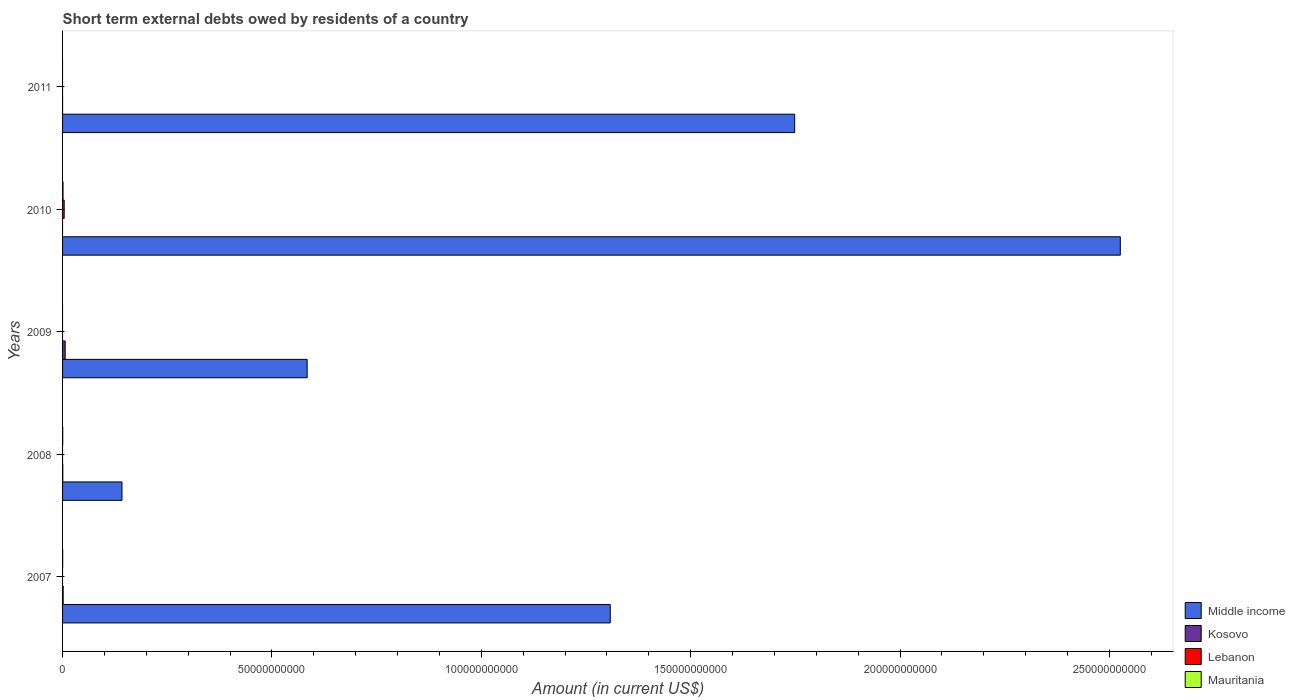How many different coloured bars are there?
Provide a short and direct response. 4. How many groups of bars are there?
Give a very brief answer. 5. Are the number of bars per tick equal to the number of legend labels?
Ensure brevity in your answer.  No. Are the number of bars on each tick of the Y-axis equal?
Your response must be concise. No. How many bars are there on the 1st tick from the top?
Your response must be concise. 2. How many bars are there on the 2nd tick from the bottom?
Your answer should be very brief. 3. What is the label of the 1st group of bars from the top?
Ensure brevity in your answer.  2011. Across all years, what is the maximum amount of short-term external debts owed by residents in Mauritania?
Your answer should be compact. 1.03e+08. Across all years, what is the minimum amount of short-term external debts owed by residents in Mauritania?
Your answer should be compact. 0. What is the total amount of short-term external debts owed by residents in Kosovo in the graph?
Make the answer very short. 8.22e+08. What is the difference between the amount of short-term external debts owed by residents in Middle income in 2009 and that in 2011?
Your answer should be compact. -1.16e+11. What is the difference between the amount of short-term external debts owed by residents in Middle income in 2010 and the amount of short-term external debts owed by residents in Mauritania in 2008?
Ensure brevity in your answer.  2.53e+11. What is the average amount of short-term external debts owed by residents in Middle income per year?
Make the answer very short. 1.26e+11. In the year 2010, what is the difference between the amount of short-term external debts owed by residents in Middle income and amount of short-term external debts owed by residents in Mauritania?
Offer a terse response. 2.52e+11. In how many years, is the amount of short-term external debts owed by residents in Lebanon greater than 160000000000 US$?
Make the answer very short. 0. What is the ratio of the amount of short-term external debts owed by residents in Kosovo in 2007 to that in 2011?
Make the answer very short. 111.99. What is the difference between the highest and the second highest amount of short-term external debts owed by residents in Middle income?
Ensure brevity in your answer.  7.78e+1. What is the difference between the highest and the lowest amount of short-term external debts owed by residents in Middle income?
Provide a succinct answer. 2.38e+11. Is the sum of the amount of short-term external debts owed by residents in Middle income in 2008 and 2011 greater than the maximum amount of short-term external debts owed by residents in Kosovo across all years?
Your answer should be very brief. Yes. Is it the case that in every year, the sum of the amount of short-term external debts owed by residents in Lebanon and amount of short-term external debts owed by residents in Kosovo is greater than the sum of amount of short-term external debts owed by residents in Middle income and amount of short-term external debts owed by residents in Mauritania?
Your answer should be compact. No. What is the difference between two consecutive major ticks on the X-axis?
Provide a short and direct response. 5.00e+1. Where does the legend appear in the graph?
Offer a very short reply. Bottom right. How many legend labels are there?
Your answer should be very brief. 4. What is the title of the graph?
Offer a terse response. Short term external debts owed by residents of a country. What is the Amount (in current US$) in Middle income in 2007?
Ensure brevity in your answer.  1.31e+11. What is the Amount (in current US$) of Kosovo in 2007?
Make the answer very short. 1.41e+08. What is the Amount (in current US$) in Lebanon in 2007?
Your response must be concise. 0. What is the Amount (in current US$) of Mauritania in 2007?
Offer a terse response. 2.70e+07. What is the Amount (in current US$) in Middle income in 2008?
Provide a short and direct response. 1.42e+1. What is the Amount (in current US$) in Kosovo in 2008?
Offer a very short reply. 5.36e+07. What is the Amount (in current US$) in Mauritania in 2008?
Make the answer very short. 4.00e+07. What is the Amount (in current US$) in Middle income in 2009?
Your answer should be very brief. 5.84e+1. What is the Amount (in current US$) in Kosovo in 2009?
Provide a succinct answer. 6.27e+08. What is the Amount (in current US$) of Lebanon in 2009?
Make the answer very short. 0. What is the Amount (in current US$) in Mauritania in 2009?
Keep it short and to the point. 0. What is the Amount (in current US$) of Middle income in 2010?
Provide a succinct answer. 2.53e+11. What is the Amount (in current US$) in Kosovo in 2010?
Keep it short and to the point. 0. What is the Amount (in current US$) in Lebanon in 2010?
Provide a short and direct response. 3.86e+08. What is the Amount (in current US$) of Mauritania in 2010?
Provide a short and direct response. 1.03e+08. What is the Amount (in current US$) of Middle income in 2011?
Provide a short and direct response. 1.75e+11. What is the Amount (in current US$) in Kosovo in 2011?
Give a very brief answer. 1.26e+06. What is the Amount (in current US$) in Lebanon in 2011?
Give a very brief answer. 0. What is the Amount (in current US$) of Mauritania in 2011?
Offer a very short reply. 0. Across all years, what is the maximum Amount (in current US$) of Middle income?
Provide a succinct answer. 2.53e+11. Across all years, what is the maximum Amount (in current US$) of Kosovo?
Offer a terse response. 6.27e+08. Across all years, what is the maximum Amount (in current US$) in Lebanon?
Your answer should be very brief. 3.86e+08. Across all years, what is the maximum Amount (in current US$) in Mauritania?
Your response must be concise. 1.03e+08. Across all years, what is the minimum Amount (in current US$) in Middle income?
Your answer should be very brief. 1.42e+1. Across all years, what is the minimum Amount (in current US$) in Kosovo?
Provide a short and direct response. 0. Across all years, what is the minimum Amount (in current US$) of Lebanon?
Offer a very short reply. 0. Across all years, what is the minimum Amount (in current US$) in Mauritania?
Provide a succinct answer. 0. What is the total Amount (in current US$) of Middle income in the graph?
Make the answer very short. 6.31e+11. What is the total Amount (in current US$) in Kosovo in the graph?
Your response must be concise. 8.22e+08. What is the total Amount (in current US$) of Lebanon in the graph?
Ensure brevity in your answer.  3.86e+08. What is the total Amount (in current US$) of Mauritania in the graph?
Make the answer very short. 1.70e+08. What is the difference between the Amount (in current US$) of Middle income in 2007 and that in 2008?
Your answer should be very brief. 1.17e+11. What is the difference between the Amount (in current US$) of Kosovo in 2007 and that in 2008?
Ensure brevity in your answer.  8.71e+07. What is the difference between the Amount (in current US$) in Mauritania in 2007 and that in 2008?
Keep it short and to the point. -1.30e+07. What is the difference between the Amount (in current US$) in Middle income in 2007 and that in 2009?
Your response must be concise. 7.24e+1. What is the difference between the Amount (in current US$) of Kosovo in 2007 and that in 2009?
Your response must be concise. -4.86e+08. What is the difference between the Amount (in current US$) in Middle income in 2007 and that in 2010?
Your response must be concise. -1.22e+11. What is the difference between the Amount (in current US$) of Mauritania in 2007 and that in 2010?
Your answer should be very brief. -7.60e+07. What is the difference between the Amount (in current US$) in Middle income in 2007 and that in 2011?
Your answer should be compact. -4.40e+1. What is the difference between the Amount (in current US$) of Kosovo in 2007 and that in 2011?
Offer a very short reply. 1.39e+08. What is the difference between the Amount (in current US$) of Middle income in 2008 and that in 2009?
Your response must be concise. -4.42e+1. What is the difference between the Amount (in current US$) in Kosovo in 2008 and that in 2009?
Offer a terse response. -5.73e+08. What is the difference between the Amount (in current US$) of Middle income in 2008 and that in 2010?
Give a very brief answer. -2.38e+11. What is the difference between the Amount (in current US$) in Mauritania in 2008 and that in 2010?
Ensure brevity in your answer.  -6.30e+07. What is the difference between the Amount (in current US$) in Middle income in 2008 and that in 2011?
Offer a very short reply. -1.61e+11. What is the difference between the Amount (in current US$) of Kosovo in 2008 and that in 2011?
Provide a short and direct response. 5.23e+07. What is the difference between the Amount (in current US$) of Middle income in 2009 and that in 2010?
Give a very brief answer. -1.94e+11. What is the difference between the Amount (in current US$) of Middle income in 2009 and that in 2011?
Provide a short and direct response. -1.16e+11. What is the difference between the Amount (in current US$) of Kosovo in 2009 and that in 2011?
Your response must be concise. 6.26e+08. What is the difference between the Amount (in current US$) of Middle income in 2010 and that in 2011?
Give a very brief answer. 7.78e+1. What is the difference between the Amount (in current US$) of Middle income in 2007 and the Amount (in current US$) of Kosovo in 2008?
Offer a very short reply. 1.31e+11. What is the difference between the Amount (in current US$) of Middle income in 2007 and the Amount (in current US$) of Mauritania in 2008?
Make the answer very short. 1.31e+11. What is the difference between the Amount (in current US$) of Kosovo in 2007 and the Amount (in current US$) of Mauritania in 2008?
Provide a short and direct response. 1.01e+08. What is the difference between the Amount (in current US$) of Middle income in 2007 and the Amount (in current US$) of Kosovo in 2009?
Ensure brevity in your answer.  1.30e+11. What is the difference between the Amount (in current US$) in Middle income in 2007 and the Amount (in current US$) in Lebanon in 2010?
Provide a short and direct response. 1.30e+11. What is the difference between the Amount (in current US$) of Middle income in 2007 and the Amount (in current US$) of Mauritania in 2010?
Make the answer very short. 1.31e+11. What is the difference between the Amount (in current US$) in Kosovo in 2007 and the Amount (in current US$) in Lebanon in 2010?
Your answer should be compact. -2.45e+08. What is the difference between the Amount (in current US$) in Kosovo in 2007 and the Amount (in current US$) in Mauritania in 2010?
Your answer should be compact. 3.77e+07. What is the difference between the Amount (in current US$) of Middle income in 2007 and the Amount (in current US$) of Kosovo in 2011?
Your response must be concise. 1.31e+11. What is the difference between the Amount (in current US$) of Middle income in 2008 and the Amount (in current US$) of Kosovo in 2009?
Offer a terse response. 1.36e+1. What is the difference between the Amount (in current US$) in Middle income in 2008 and the Amount (in current US$) in Lebanon in 2010?
Provide a short and direct response. 1.38e+1. What is the difference between the Amount (in current US$) of Middle income in 2008 and the Amount (in current US$) of Mauritania in 2010?
Your answer should be very brief. 1.41e+1. What is the difference between the Amount (in current US$) in Kosovo in 2008 and the Amount (in current US$) in Lebanon in 2010?
Provide a succinct answer. -3.32e+08. What is the difference between the Amount (in current US$) in Kosovo in 2008 and the Amount (in current US$) in Mauritania in 2010?
Your answer should be very brief. -4.94e+07. What is the difference between the Amount (in current US$) of Middle income in 2008 and the Amount (in current US$) of Kosovo in 2011?
Keep it short and to the point. 1.42e+1. What is the difference between the Amount (in current US$) of Middle income in 2009 and the Amount (in current US$) of Lebanon in 2010?
Give a very brief answer. 5.80e+1. What is the difference between the Amount (in current US$) in Middle income in 2009 and the Amount (in current US$) in Mauritania in 2010?
Your response must be concise. 5.83e+1. What is the difference between the Amount (in current US$) of Kosovo in 2009 and the Amount (in current US$) of Lebanon in 2010?
Your answer should be compact. 2.41e+08. What is the difference between the Amount (in current US$) in Kosovo in 2009 and the Amount (in current US$) in Mauritania in 2010?
Offer a very short reply. 5.24e+08. What is the difference between the Amount (in current US$) in Middle income in 2009 and the Amount (in current US$) in Kosovo in 2011?
Provide a short and direct response. 5.84e+1. What is the difference between the Amount (in current US$) of Middle income in 2010 and the Amount (in current US$) of Kosovo in 2011?
Give a very brief answer. 2.53e+11. What is the average Amount (in current US$) of Middle income per year?
Keep it short and to the point. 1.26e+11. What is the average Amount (in current US$) in Kosovo per year?
Make the answer very short. 1.64e+08. What is the average Amount (in current US$) of Lebanon per year?
Offer a terse response. 7.72e+07. What is the average Amount (in current US$) of Mauritania per year?
Give a very brief answer. 3.40e+07. In the year 2007, what is the difference between the Amount (in current US$) in Middle income and Amount (in current US$) in Kosovo?
Provide a succinct answer. 1.31e+11. In the year 2007, what is the difference between the Amount (in current US$) of Middle income and Amount (in current US$) of Mauritania?
Give a very brief answer. 1.31e+11. In the year 2007, what is the difference between the Amount (in current US$) in Kosovo and Amount (in current US$) in Mauritania?
Provide a short and direct response. 1.14e+08. In the year 2008, what is the difference between the Amount (in current US$) in Middle income and Amount (in current US$) in Kosovo?
Give a very brief answer. 1.41e+1. In the year 2008, what is the difference between the Amount (in current US$) in Middle income and Amount (in current US$) in Mauritania?
Provide a short and direct response. 1.42e+1. In the year 2008, what is the difference between the Amount (in current US$) in Kosovo and Amount (in current US$) in Mauritania?
Give a very brief answer. 1.36e+07. In the year 2009, what is the difference between the Amount (in current US$) in Middle income and Amount (in current US$) in Kosovo?
Ensure brevity in your answer.  5.78e+1. In the year 2010, what is the difference between the Amount (in current US$) of Middle income and Amount (in current US$) of Lebanon?
Provide a short and direct response. 2.52e+11. In the year 2010, what is the difference between the Amount (in current US$) of Middle income and Amount (in current US$) of Mauritania?
Your response must be concise. 2.52e+11. In the year 2010, what is the difference between the Amount (in current US$) in Lebanon and Amount (in current US$) in Mauritania?
Offer a terse response. 2.83e+08. In the year 2011, what is the difference between the Amount (in current US$) of Middle income and Amount (in current US$) of Kosovo?
Your answer should be very brief. 1.75e+11. What is the ratio of the Amount (in current US$) in Middle income in 2007 to that in 2008?
Keep it short and to the point. 9.22. What is the ratio of the Amount (in current US$) in Kosovo in 2007 to that in 2008?
Your answer should be very brief. 2.63. What is the ratio of the Amount (in current US$) of Mauritania in 2007 to that in 2008?
Give a very brief answer. 0.68. What is the ratio of the Amount (in current US$) in Middle income in 2007 to that in 2009?
Provide a short and direct response. 2.24. What is the ratio of the Amount (in current US$) in Kosovo in 2007 to that in 2009?
Provide a short and direct response. 0.22. What is the ratio of the Amount (in current US$) of Middle income in 2007 to that in 2010?
Offer a terse response. 0.52. What is the ratio of the Amount (in current US$) of Mauritania in 2007 to that in 2010?
Your answer should be very brief. 0.26. What is the ratio of the Amount (in current US$) in Middle income in 2007 to that in 2011?
Your answer should be very brief. 0.75. What is the ratio of the Amount (in current US$) in Kosovo in 2007 to that in 2011?
Keep it short and to the point. 111.99. What is the ratio of the Amount (in current US$) in Middle income in 2008 to that in 2009?
Your answer should be compact. 0.24. What is the ratio of the Amount (in current US$) of Kosovo in 2008 to that in 2009?
Keep it short and to the point. 0.09. What is the ratio of the Amount (in current US$) of Middle income in 2008 to that in 2010?
Offer a very short reply. 0.06. What is the ratio of the Amount (in current US$) of Mauritania in 2008 to that in 2010?
Offer a terse response. 0.39. What is the ratio of the Amount (in current US$) in Middle income in 2008 to that in 2011?
Your response must be concise. 0.08. What is the ratio of the Amount (in current US$) of Kosovo in 2008 to that in 2011?
Provide a short and direct response. 42.66. What is the ratio of the Amount (in current US$) in Middle income in 2009 to that in 2010?
Your answer should be compact. 0.23. What is the ratio of the Amount (in current US$) of Middle income in 2009 to that in 2011?
Your answer should be compact. 0.33. What is the ratio of the Amount (in current US$) in Kosovo in 2009 to that in 2011?
Keep it short and to the point. 499.12. What is the ratio of the Amount (in current US$) of Middle income in 2010 to that in 2011?
Provide a short and direct response. 1.44. What is the difference between the highest and the second highest Amount (in current US$) of Middle income?
Give a very brief answer. 7.78e+1. What is the difference between the highest and the second highest Amount (in current US$) in Kosovo?
Your response must be concise. 4.86e+08. What is the difference between the highest and the second highest Amount (in current US$) of Mauritania?
Your answer should be compact. 6.30e+07. What is the difference between the highest and the lowest Amount (in current US$) in Middle income?
Offer a very short reply. 2.38e+11. What is the difference between the highest and the lowest Amount (in current US$) of Kosovo?
Provide a short and direct response. 6.27e+08. What is the difference between the highest and the lowest Amount (in current US$) of Lebanon?
Make the answer very short. 3.86e+08. What is the difference between the highest and the lowest Amount (in current US$) of Mauritania?
Provide a succinct answer. 1.03e+08. 